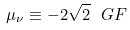<formula> <loc_0><loc_0><loc_500><loc_500>\mu _ { \nu } \equiv - 2 \sqrt { 2 } \ G F</formula> 